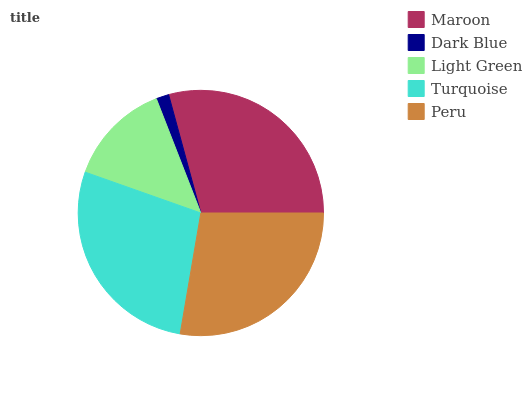Is Dark Blue the minimum?
Answer yes or no. Yes. Is Maroon the maximum?
Answer yes or no. Yes. Is Light Green the minimum?
Answer yes or no. No. Is Light Green the maximum?
Answer yes or no. No. Is Light Green greater than Dark Blue?
Answer yes or no. Yes. Is Dark Blue less than Light Green?
Answer yes or no. Yes. Is Dark Blue greater than Light Green?
Answer yes or no. No. Is Light Green less than Dark Blue?
Answer yes or no. No. Is Peru the high median?
Answer yes or no. Yes. Is Peru the low median?
Answer yes or no. Yes. Is Maroon the high median?
Answer yes or no. No. Is Dark Blue the low median?
Answer yes or no. No. 